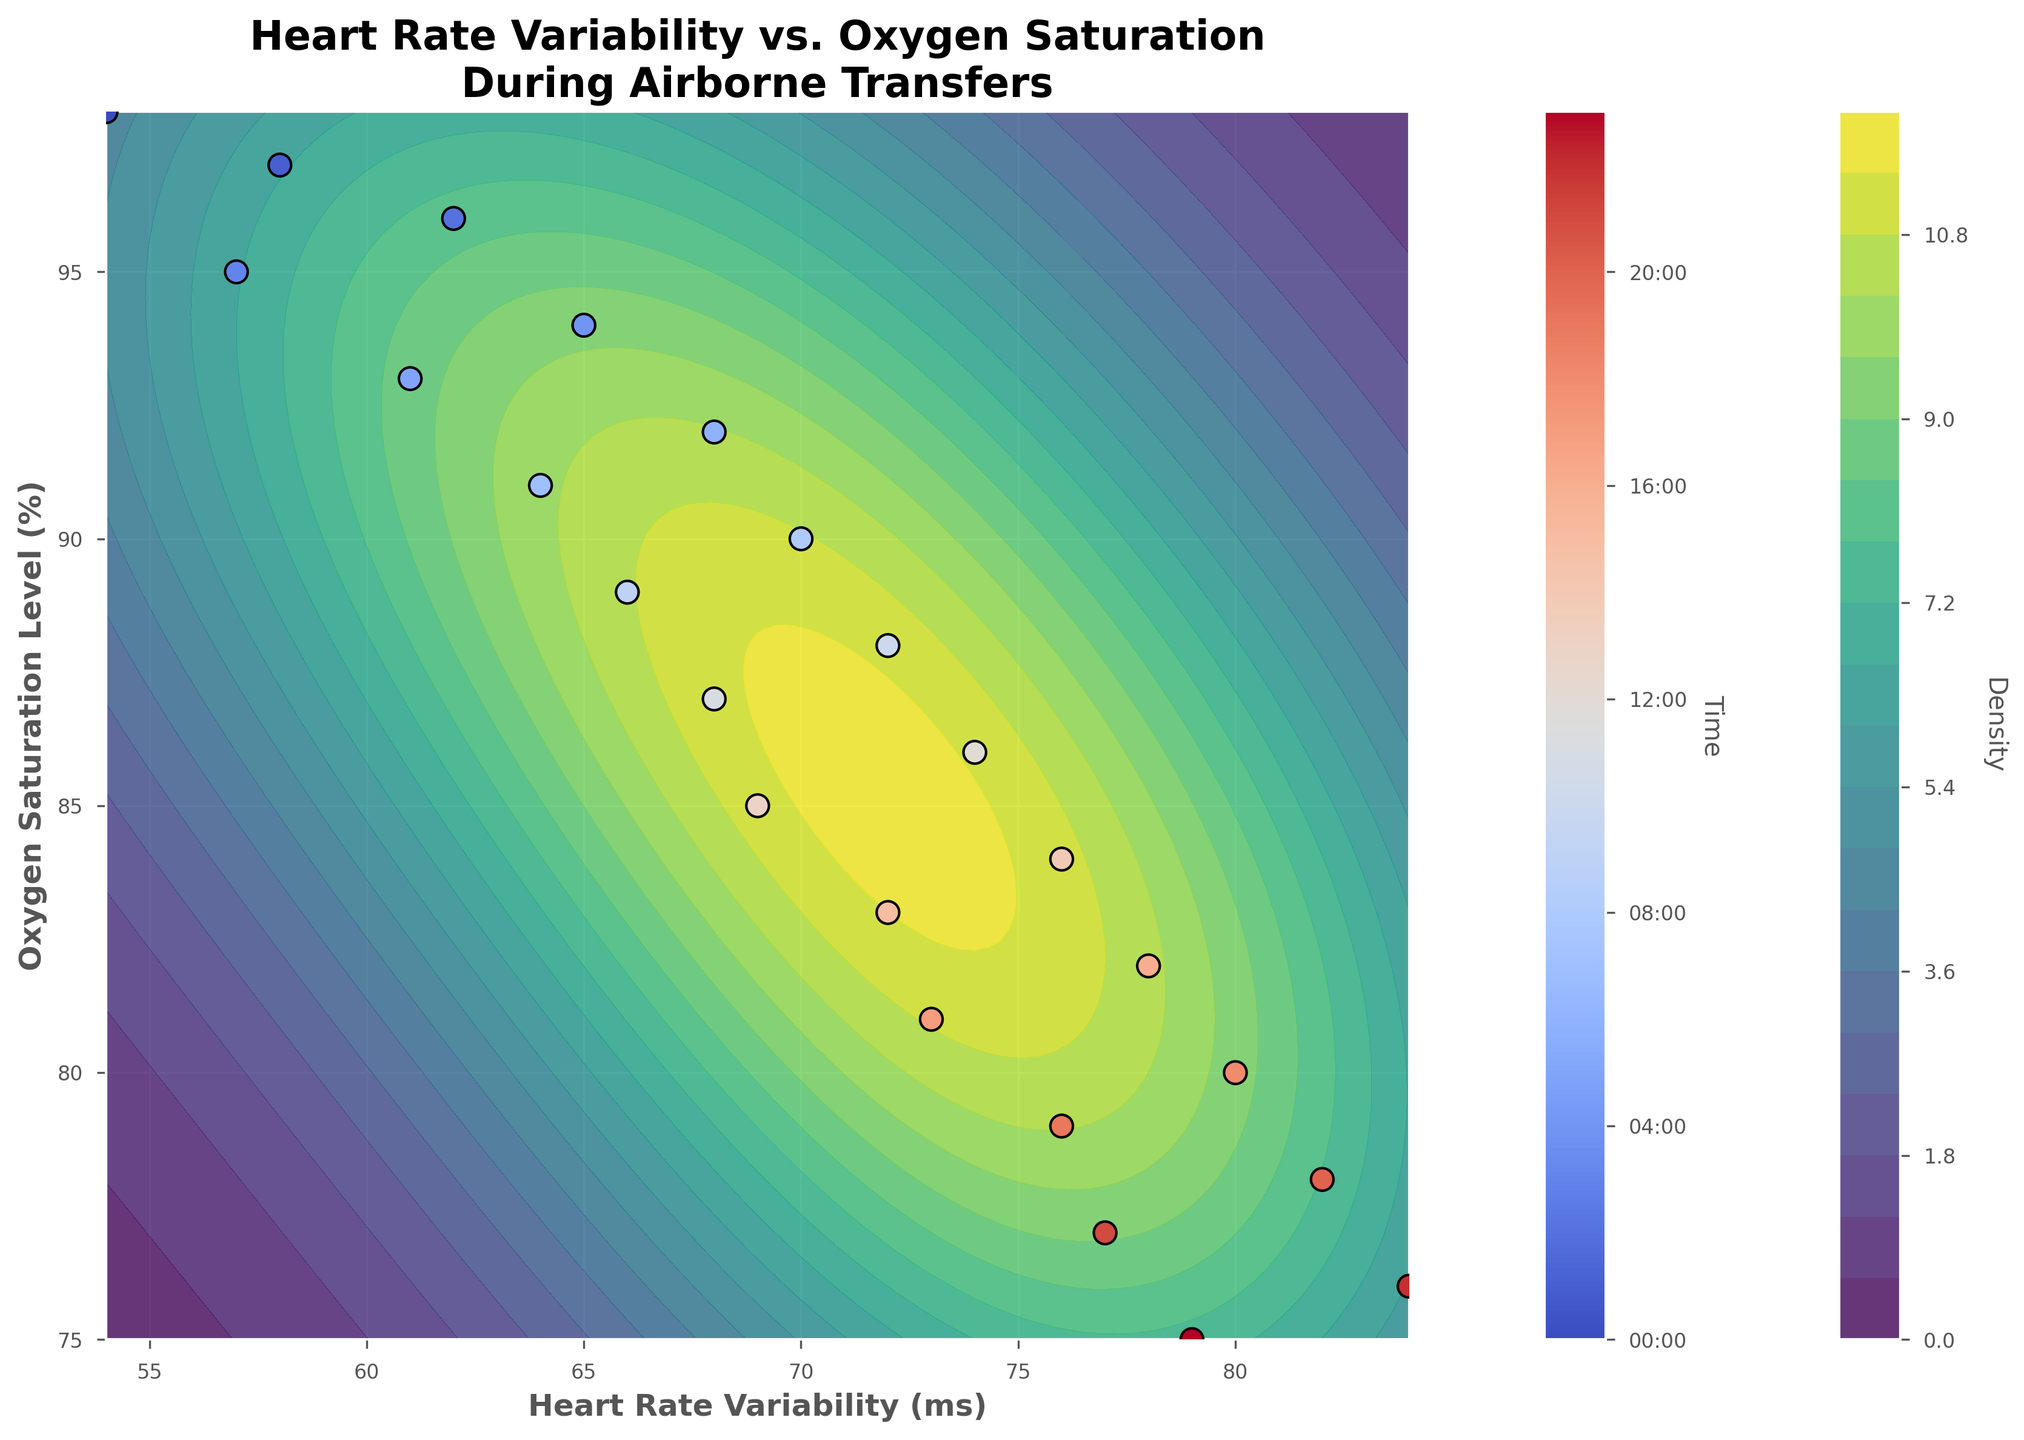What is the title of the plot? The title of the plot is displayed at the top and provides a short description of what the plot represents. The title is "Heart Rate Variability vs. Oxygen Saturation\nDuring Airborne Transfers".
Answer: Heart Rate Variability vs. Oxygen Saturation During Airborne Transfers What is the range of Heart Rate Variability (HRV) in milliseconds? The range of HRV can be found by observing the x-axis. The minimum HRV is 54 ms, and the maximum HRV is 84 ms.
Answer: 54 to 84 ms During what time period is the highest Heart Rate Variability observed? The color-coded scatter plot points indicate the time. The darkest dot, corresponding to the highest HRV around 84 ms, appears between 22:00 and 23:00.
Answer: Between 22:00 and 23:00 Which axis represents Oxygen Saturation Levels, and what are its units? The oxygen saturation levels are represented on the y-axis, and the units are given as percentages (%).
Answer: y-axis, % What is the lowest Oxygen Saturation Level, and at what time does it occur? The color-coded scatter plot points indicate the time. The lowest oxygen saturation level (75%) is observed at 23:00.
Answer: 75%, at 23:00 Which time period shows the highest density of data points in terms of HRV and oxygen saturation levels? The highest density can be identified by the darkest regions in the contour plot. This region is located between an HRV of approximately 68 ms and 76 ms and oxygen saturation levels around 87% to 79%. The scatter plot points around these values mostly correspond to times between 12:00 and 20:00 based on their colors.
Answer: Between 12:00 and 20:00 What is the trend in oxygen saturation levels as heart rate variability increases from 54 ms to 84 ms? By observing the scatter plot, it's evident that as HRV increases from 54 ms to 84 ms, the oxygen saturation levels decrease from 98% to 75%.
Answer: Decreasing At what time does Heart Rate Variability (HRV) first surpass 80 ms? By examining the scatter plot and referencing the color-coded time bar, the time at which HRV first surpasses 80 ms is around 18:00.
Answer: Around 18:00 Which appears to change more rapidly during the transfers – Heart Rate Variability or Oxygen Saturation Levels, and how do you deduce this from the plot? Heart Rate Variability changes from 54 ms to 84 ms, a difference of 30 ms. Oxygen saturation levels change from 98% to 75%, a difference of 23%. Though the absolute differences seem similar, the contour plot shows higher deviations and more scattered values in the HRV, suggesting it changes more rapidly.
Answer: Heart Rate Variability How does the colorbar on the right side of the scatter plot assist in interpreting the time dimension? The colorbar on the right side of the scatter plot is graduated from the lightest to the darkest color, corresponding to times from 00:00 to 23:00. Each scatter point's color matches a specific hour, allowing us to associate the HRV and oxygen saturation values with specific times throughout the 24-hour period. This facilitates understanding changes over time.
Answer: It provides a time scale 